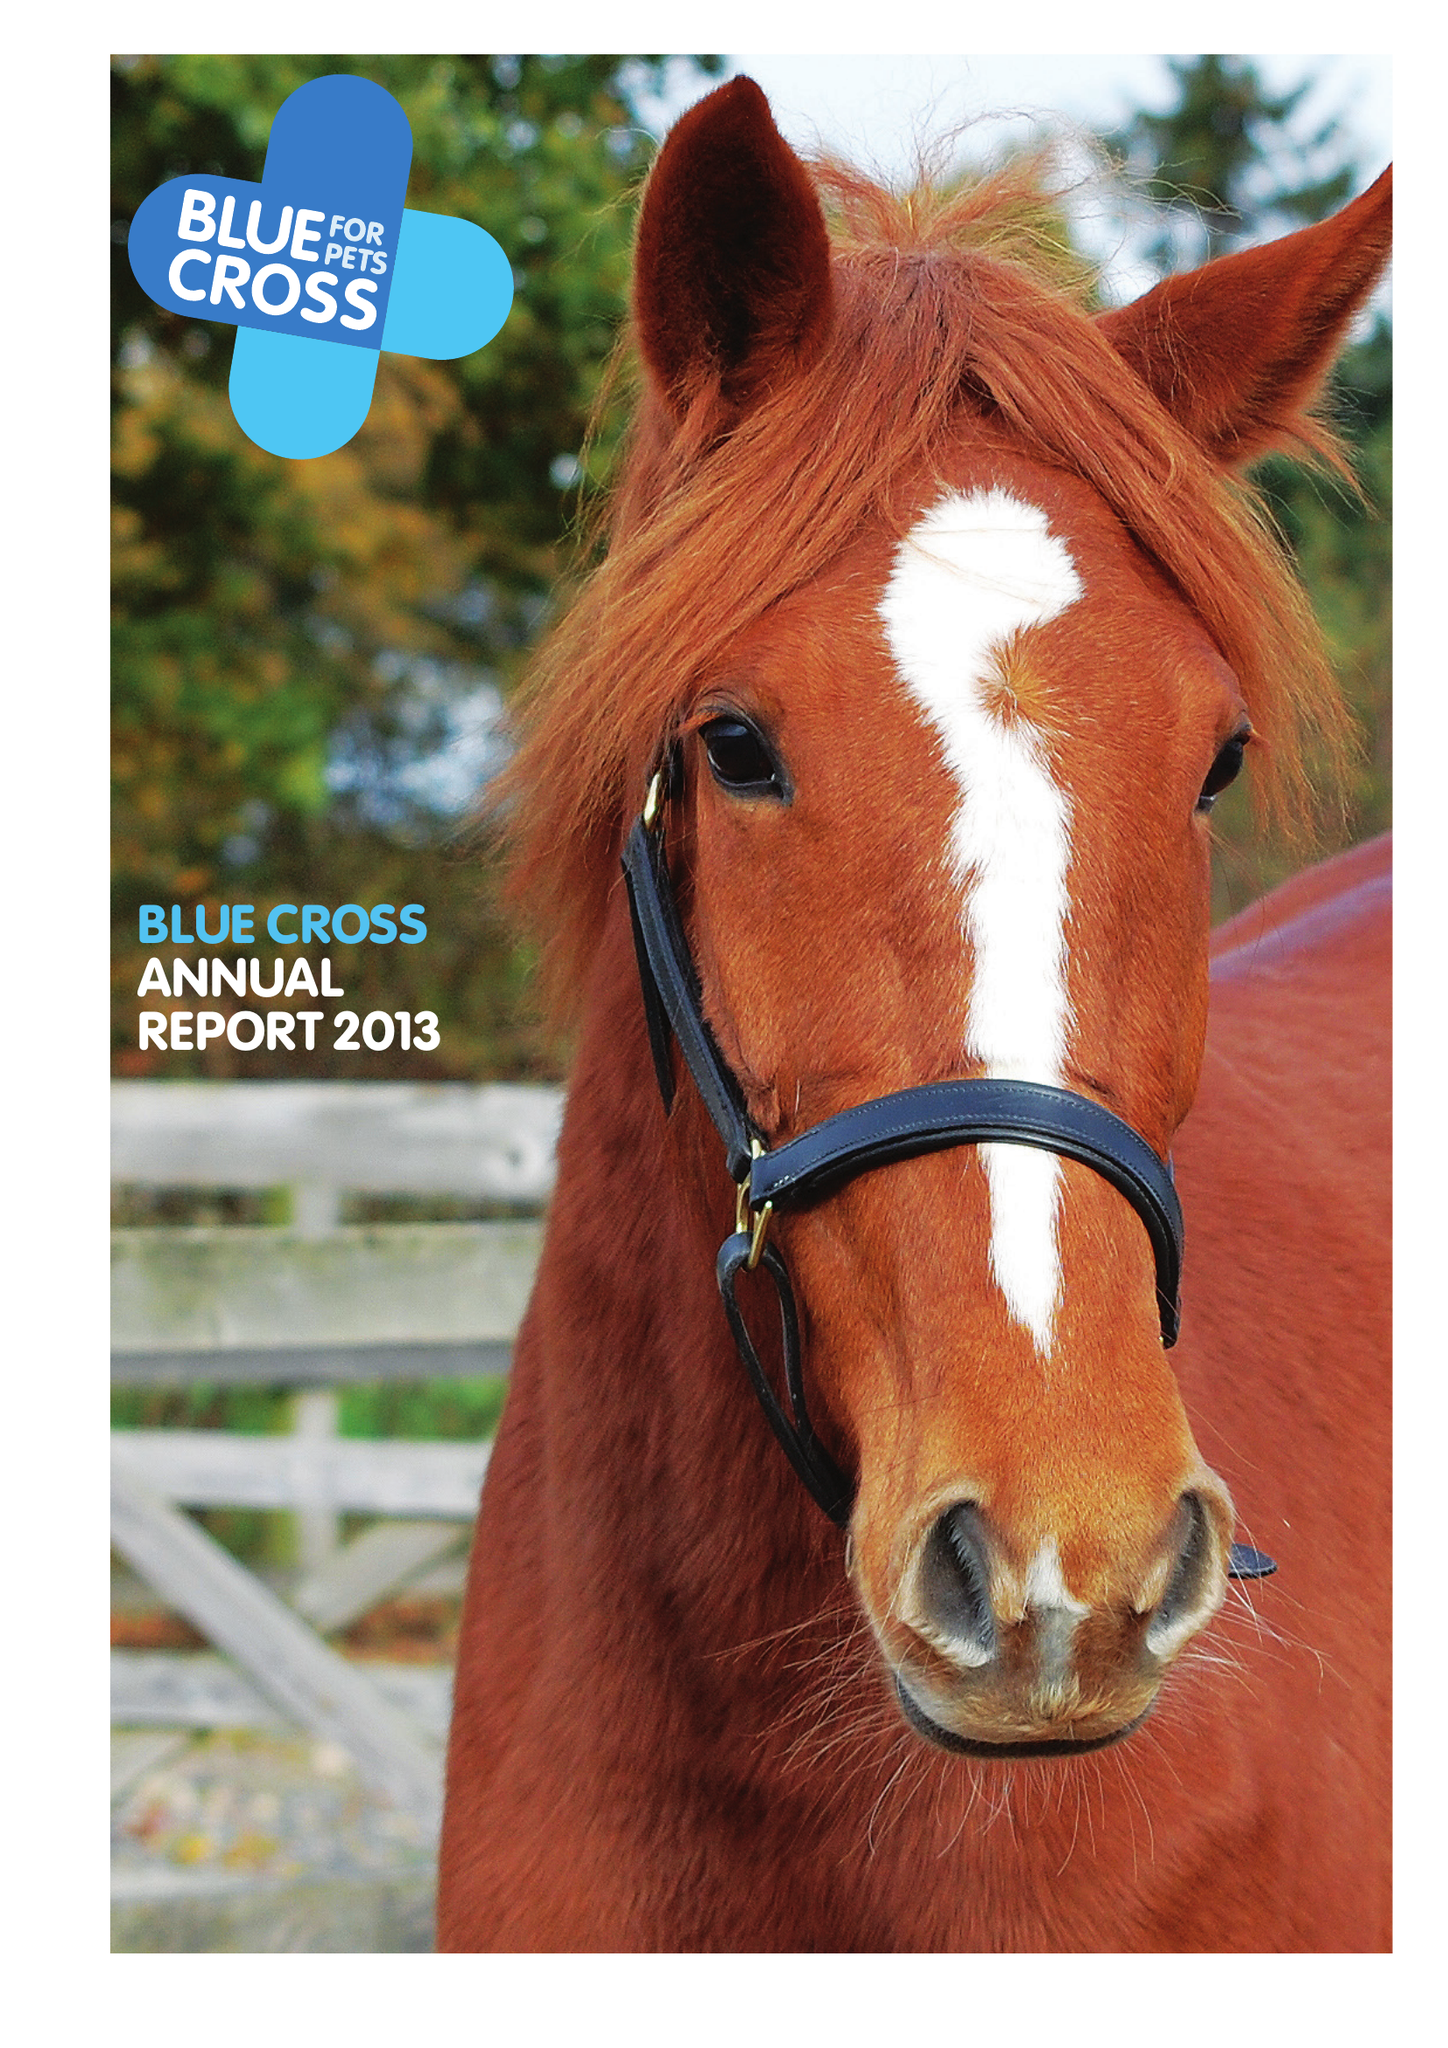What is the value for the address__post_town?
Answer the question using a single word or phrase. CARTERTON 